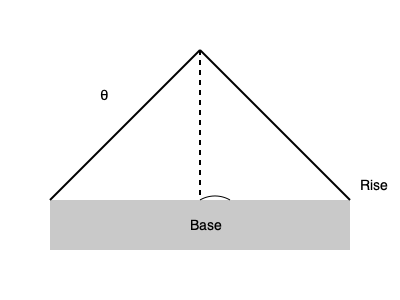As a homeowner working on your dream house, you've learned that the roof pitch angle affects energy efficiency. Given that the optimal angle for solar panels in your area is 30°, and considering factors like snow load and attic ventilation, what should be the rise-to-run ratio of your roof to achieve this optimal angle? To determine the rise-to-run ratio for the optimal roof pitch angle, we'll follow these steps:

1. Recall the tangent function relates the angle to the rise and run:
   $\tan(\theta) = \frac{\text{rise}}{\text{run}}$

2. We're given the optimal angle θ = 30°. Let's calculate the tangent:
   $\tan(30°) = \frac{\sqrt{3}}{3} \approx 0.577$

3. This means that for every unit of run, we need 0.577 units of rise.

4. To express this as a ratio, we can multiply both sides by 12 (a common unit in construction):
   $0.577 \times 12 \approx 6.93$

5. Rounding to the nearest whole number for practical construction:
   Rise : Run = 7 : 12

This ratio means that for every 12 inches of horizontal run, the roof should rise 7 inches vertically to achieve a pitch angle close to 30°.
Answer: 7:12 